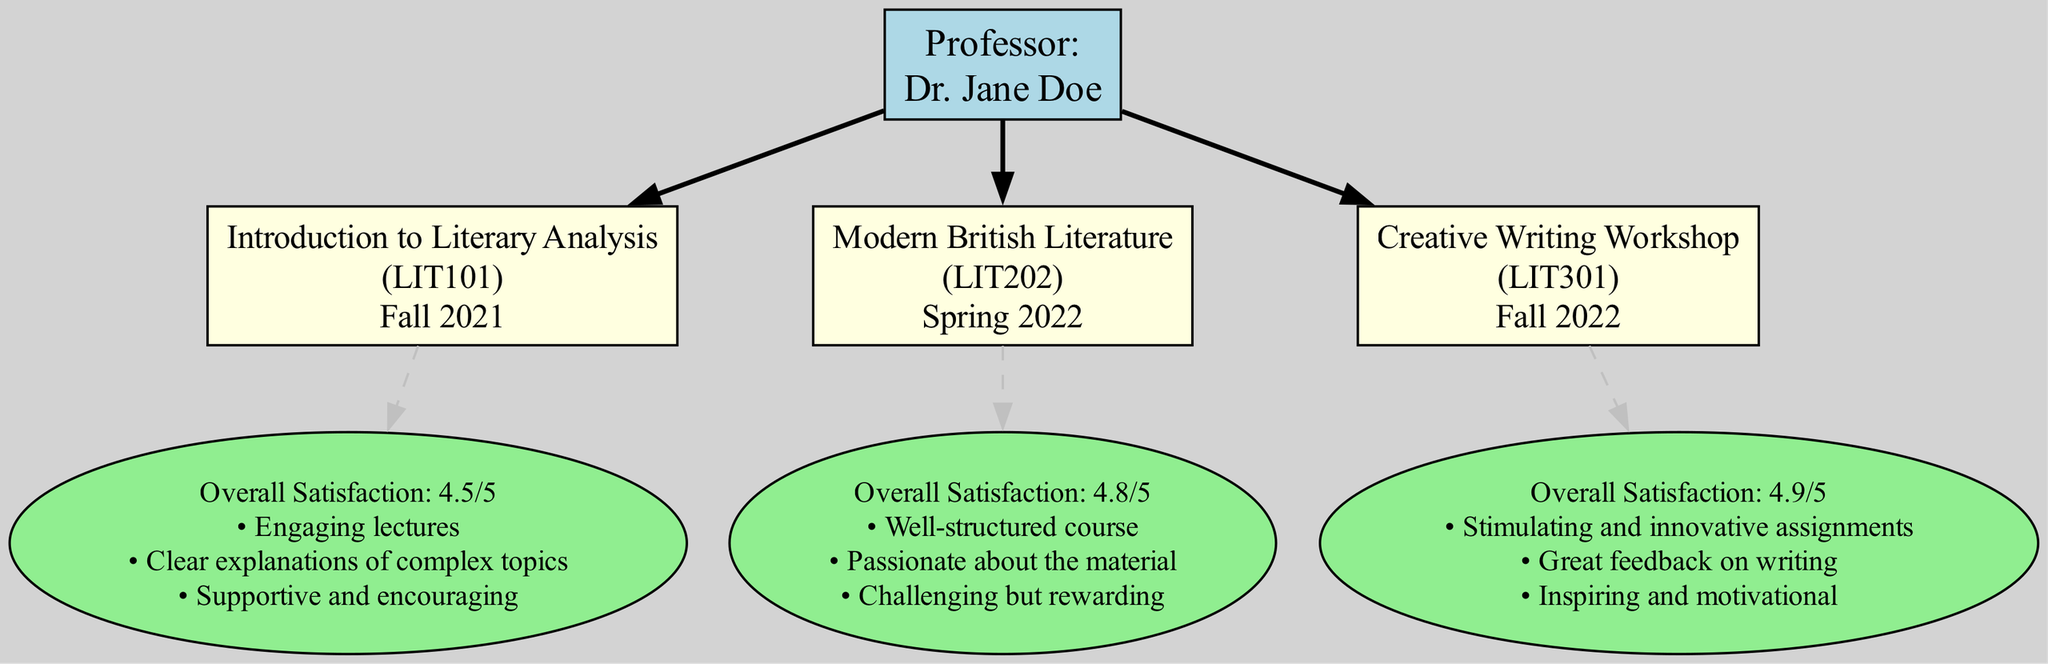What is the name of the professor in the diagram? The diagram prominently mentions the professor's name as "Dr. Jane Doe" in the main node.
Answer: Dr. Jane Doe How many courses are taught by the professor? The diagram contains three distinct course nodes, each representing a course taught by the professor.
Answer: 3 What is the overall satisfaction rating for the "Creative Writing Workshop"? The feedback node connected to the "Creative Writing Workshop" indicates an overall satisfaction rating of 4.9 out of 5.
Answer: 4.9 What comments do students have about the "Modern British Literature" course? The feedback node for "Modern British Literature" lists three students' comments including "Well-structured course," "Passionate about the material," and "Challenging but rewarding."
Answer: Well-structured course, Passionate about the material, Challenging but rewarding Which course has the highest overall satisfaction rating? Based on the overall satisfaction ratings presented in the feedback nodes, "Creative Writing Workshop" has the highest rating of 4.9, compared to the others.
Answer: Creative Writing Workshop What shape represents the professor in the diagram? The diagram shows the main node for the professor as a rectangle, which is characteristic for representing primary entities.
Answer: Rectangle What is the relationship between the professor and the courses? The diagram uses bold edges to connect the professor node to each course node, indicating that the professor teaches these courses.
Answer: Teaches Which semester was "Introduction to Literary Analysis" taught? The course node for "Introduction to Literary Analysis" clearly specifies that it was taught in the "Fall 2021" semester.
Answer: Fall 2021 What color is used for the feedback nodes in the diagram? The feedback nodes are represented using an ellipse shape filled with light green color, indicating a distinct category of information.
Answer: Light green What comment is associated with the "Creative Writing Workshop"? The feedback node for "Creative Writing Workshop" includes the comment "Stimulating and innovative assignments," showcasing specific student thoughts.
Answer: Stimulating and innovative assignments 